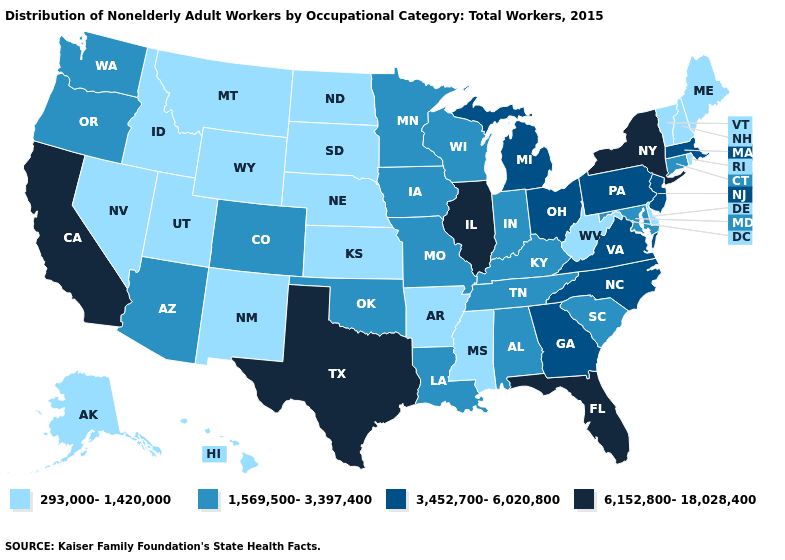Does the first symbol in the legend represent the smallest category?
Keep it brief. Yes. Name the states that have a value in the range 3,452,700-6,020,800?
Be succinct. Georgia, Massachusetts, Michigan, New Jersey, North Carolina, Ohio, Pennsylvania, Virginia. What is the value of North Dakota?
Be succinct. 293,000-1,420,000. Does the first symbol in the legend represent the smallest category?
Quick response, please. Yes. Name the states that have a value in the range 6,152,800-18,028,400?
Write a very short answer. California, Florida, Illinois, New York, Texas. Which states have the lowest value in the USA?
Keep it brief. Alaska, Arkansas, Delaware, Hawaii, Idaho, Kansas, Maine, Mississippi, Montana, Nebraska, Nevada, New Hampshire, New Mexico, North Dakota, Rhode Island, South Dakota, Utah, Vermont, West Virginia, Wyoming. Name the states that have a value in the range 6,152,800-18,028,400?
Quick response, please. California, Florida, Illinois, New York, Texas. What is the value of Alaska?
Short answer required. 293,000-1,420,000. Name the states that have a value in the range 293,000-1,420,000?
Give a very brief answer. Alaska, Arkansas, Delaware, Hawaii, Idaho, Kansas, Maine, Mississippi, Montana, Nebraska, Nevada, New Hampshire, New Mexico, North Dakota, Rhode Island, South Dakota, Utah, Vermont, West Virginia, Wyoming. Among the states that border Colorado , does Arizona have the lowest value?
Give a very brief answer. No. Among the states that border South Carolina , which have the highest value?
Short answer required. Georgia, North Carolina. Among the states that border North Carolina , does Georgia have the lowest value?
Quick response, please. No. Does New York have the same value as Florida?
Be succinct. Yes. What is the value of West Virginia?
Quick response, please. 293,000-1,420,000. What is the value of Georgia?
Be succinct. 3,452,700-6,020,800. 